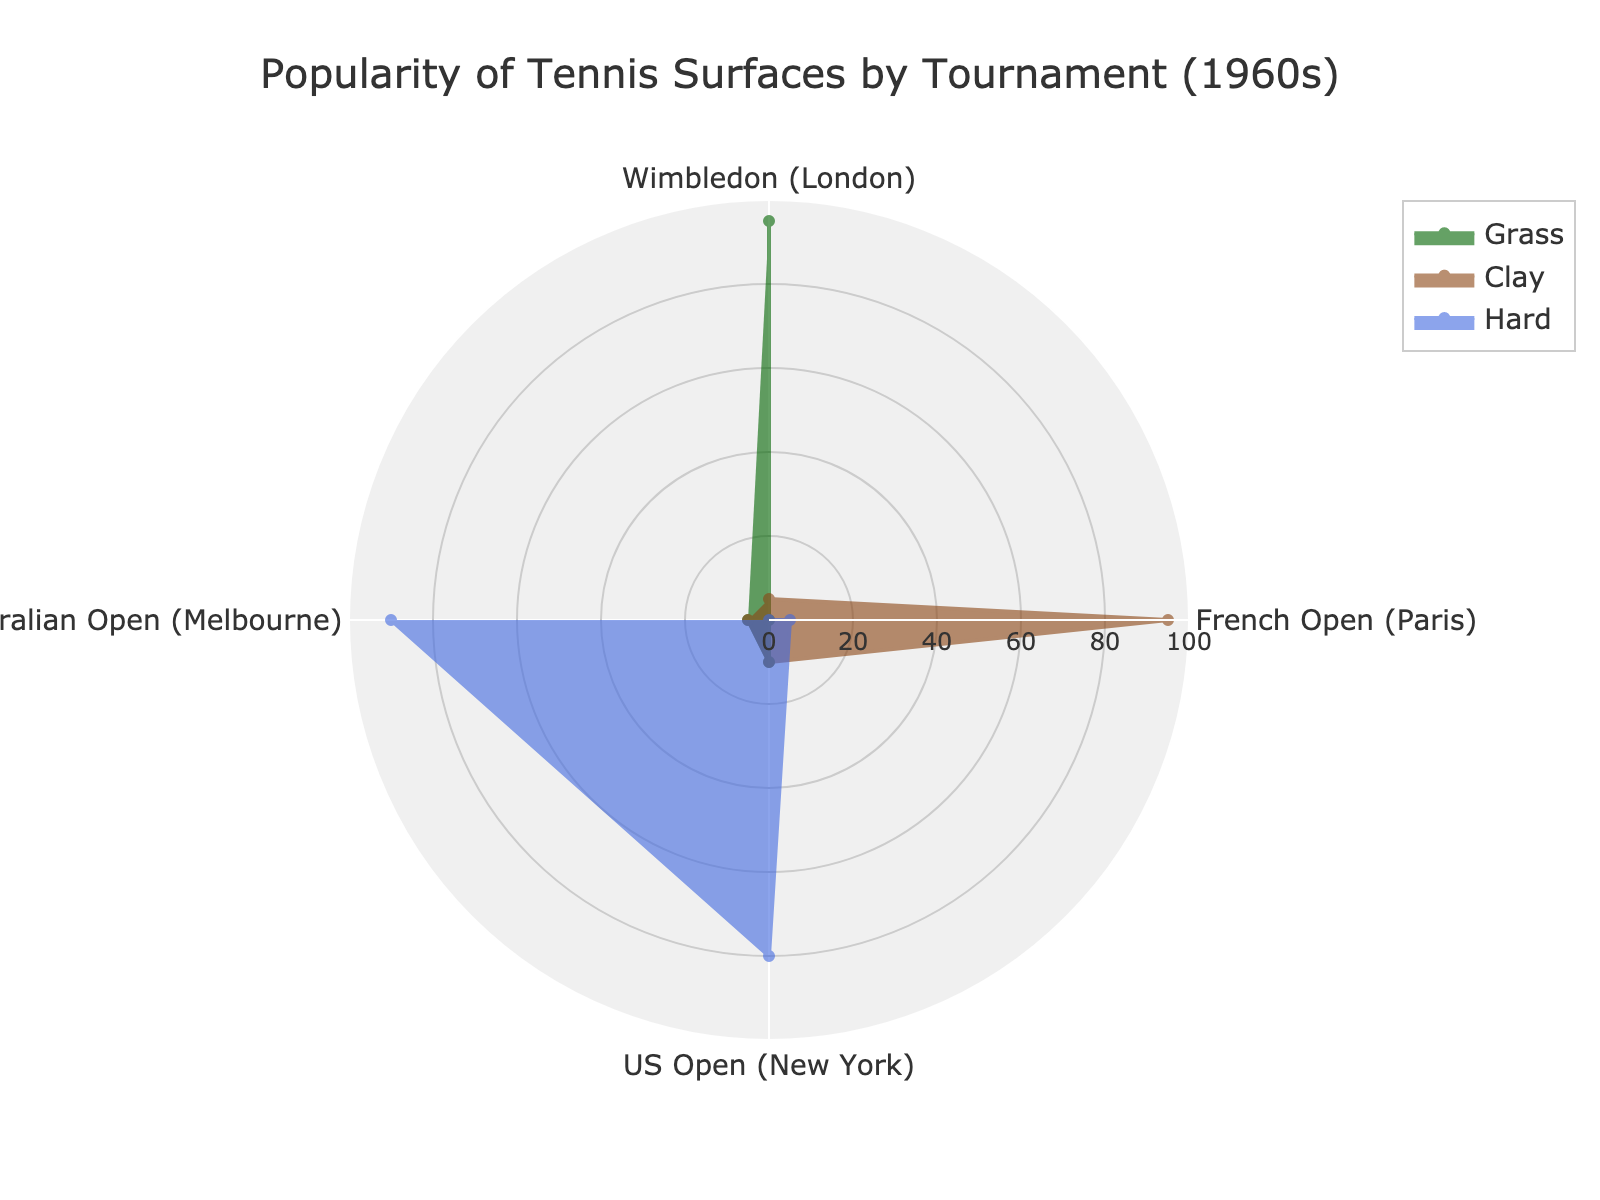What is the title of the chart? The title is located at the top center of the chart. It provides an overview of the data presented.
Answer: Popularity of Tennis Surfaces by Tournament (1960s) Which tournament has the highest popularity for Grass surfaces? The green section corresponding to Grass surfaces shows the highest value at Wimbledon.
Answer: Wimbledon (London) What is the range of the radial axis? The radial axis, which measures the popularity percentage, ranges from 0 to 100. This is visible at the outer circular grid.
Answer: 0 to 100 Which surface has the lowest popularity at the US Open? Looking at the segments for the US Open (New York), the green section for Grass surfaces is the smallest.
Answer: Grass Compare the popularity of Clay at Wimbledon and the French Open. Which tournament has a higher value? By observing the sections for Clay surfaces, the French Open has a nearly full segment, indicating a higher value compared to the much smaller section for Wimbledon.
Answer: French Open (Paris) Calculate the average popularity for Grass surfaces across all tournaments. The popularity values for Grass are 95 (Wimbledon), 0 (French Open), 10 (US Open), and 5 (Australian Open). Sum these values and divide by the number of tournaments: (95 + 0 + 10 + 5) / 4 = 110 / 4 = 27.5
Answer: 27.5 Which surface is most favored in the Australian Open? The largest section for the Australian Open corresponds to the blue section, indicating Hard surfaces.
Answer: Hard How does the popularity of Hard surfaces at the Australian Open compare to the US Open? The blue sections for Hard surfaces are both quite large, but the Australian Open's section is slightly larger than the US Open's section.
Answer: Higher at Australian Open Determine the tournament with the most balanced (equal) popularity among all three surfaces. The tournament with the most equal-sized sections for Grass, Clay, and Hard is the US Open (New York), where all three sections are relatively close in size.
Answer: US Open (New York) What is the combined popularity percentage of Clay and Hard surfaces at the French Open? For the French Open, the Clay surface has 95% and Hard surface has 5%. Adding these values gives a combined popularity of 95 + 5 = 100%.
Answer: 100 